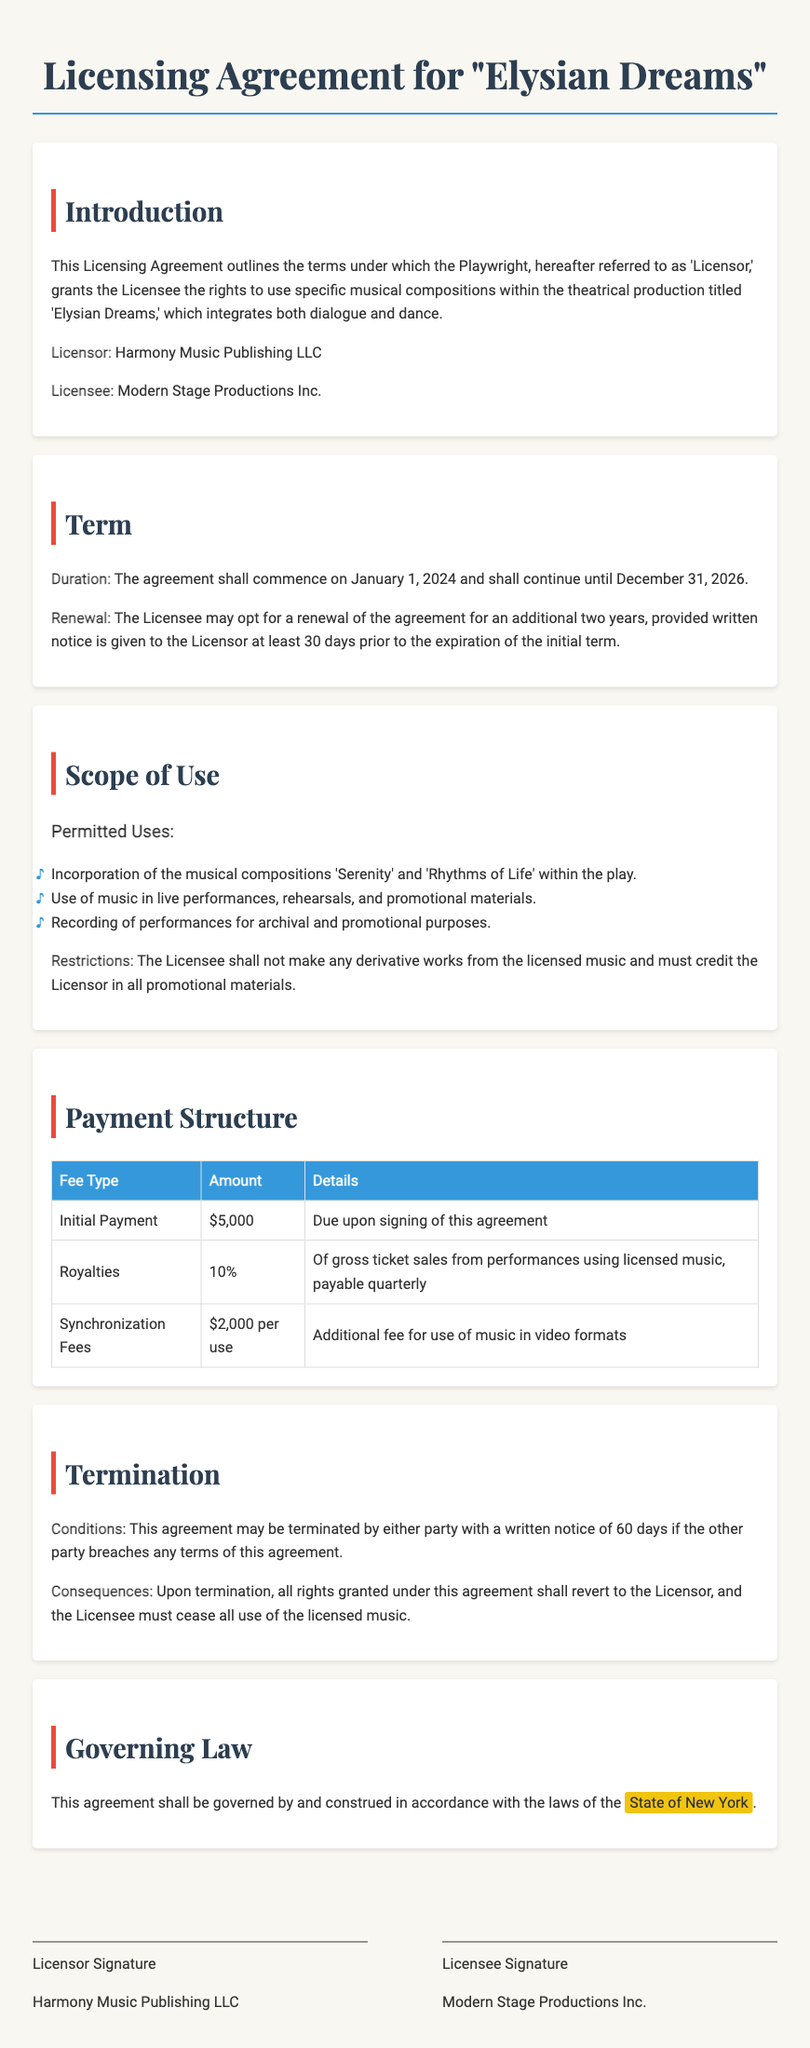What is the name of the play? The name of the play is specified in the title of the document.
Answer: Elysian Dreams Who is the Licensor? The Licensor's name is mentioned in the introduction section under the Licensor label.
Answer: Harmony Music Publishing LLC What is the duration of the agreement? The duration is stated in the Term section of the document.
Answer: January 1, 2024 to December 31, 2026 What percentage of royalties does the Licensee pay? The percentage of royalties is specified in the Payment Structure section.
Answer: 10% What must be done to renew the agreement? The renewal requirements are outlined in the Term section and explain what the Licensee needs to do.
Answer: Written notice at least 30 days prior to expiration What happens upon termination of the agreement? The consequences of termination are outlined in the Termination section.
Answer: Rights revert to the Licensor What types of uses are permitted for the music? The document specifies permitted uses in the Scope of Use section.
Answer: Live performances, rehearsals, and promotional materials What is the initial payment amount? The initial payment amount is listed under the Payment Structure section.
Answer: $5,000 In which state is the agreement governed? The governing law is mentioned in the Governing Law section of the document.
Answer: State of New York 